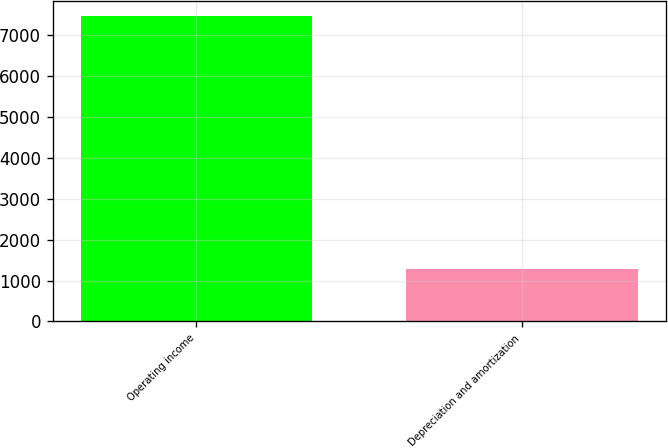Convert chart to OTSL. <chart><loc_0><loc_0><loc_500><loc_500><bar_chart><fcel>Operating income<fcel>Depreciation and amortization<nl><fcel>7473.1<fcel>1276.2<nl></chart> 